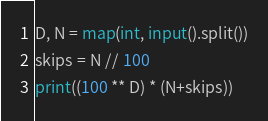Convert code to text. <code><loc_0><loc_0><loc_500><loc_500><_Python_>D, N = map(int, input().split())
skips = N // 100
print((100 ** D) * (N+skips))
</code> 